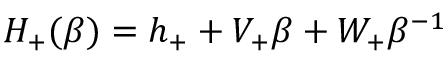Convert formula to latex. <formula><loc_0><loc_0><loc_500><loc_500>H _ { + } ( \beta ) = h _ { + } + V _ { + } \beta + W _ { + } \beta ^ { - 1 }</formula> 